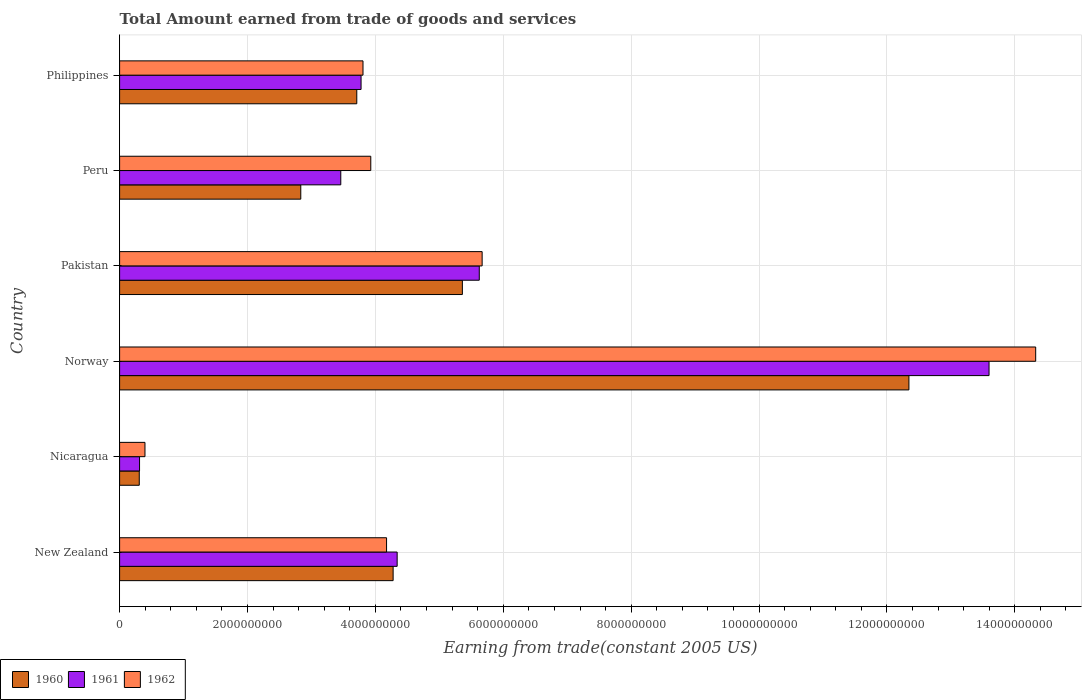How many different coloured bars are there?
Your answer should be compact. 3. How many groups of bars are there?
Provide a succinct answer. 6. Are the number of bars per tick equal to the number of legend labels?
Ensure brevity in your answer.  Yes. How many bars are there on the 6th tick from the top?
Keep it short and to the point. 3. How many bars are there on the 6th tick from the bottom?
Keep it short and to the point. 3. What is the label of the 4th group of bars from the top?
Offer a terse response. Norway. In how many cases, is the number of bars for a given country not equal to the number of legend labels?
Your answer should be compact. 0. What is the total amount earned by trading goods and services in 1960 in New Zealand?
Ensure brevity in your answer.  4.28e+09. Across all countries, what is the maximum total amount earned by trading goods and services in 1962?
Provide a short and direct response. 1.43e+1. Across all countries, what is the minimum total amount earned by trading goods and services in 1960?
Ensure brevity in your answer.  3.07e+08. In which country was the total amount earned by trading goods and services in 1960 minimum?
Your response must be concise. Nicaragua. What is the total total amount earned by trading goods and services in 1962 in the graph?
Provide a succinct answer. 3.23e+1. What is the difference between the total amount earned by trading goods and services in 1960 in Norway and that in Peru?
Keep it short and to the point. 9.51e+09. What is the difference between the total amount earned by trading goods and services in 1962 in Nicaragua and the total amount earned by trading goods and services in 1960 in Philippines?
Ensure brevity in your answer.  -3.31e+09. What is the average total amount earned by trading goods and services in 1960 per country?
Provide a succinct answer. 4.81e+09. What is the difference between the total amount earned by trading goods and services in 1960 and total amount earned by trading goods and services in 1962 in New Zealand?
Ensure brevity in your answer.  1.03e+08. What is the ratio of the total amount earned by trading goods and services in 1961 in New Zealand to that in Pakistan?
Keep it short and to the point. 0.77. Is the total amount earned by trading goods and services in 1960 in New Zealand less than that in Peru?
Your answer should be compact. No. What is the difference between the highest and the second highest total amount earned by trading goods and services in 1960?
Keep it short and to the point. 6.98e+09. What is the difference between the highest and the lowest total amount earned by trading goods and services in 1962?
Your answer should be very brief. 1.39e+1. What does the 1st bar from the top in Norway represents?
Your answer should be very brief. 1962. What does the 2nd bar from the bottom in Nicaragua represents?
Your answer should be very brief. 1961. Is it the case that in every country, the sum of the total amount earned by trading goods and services in 1962 and total amount earned by trading goods and services in 1961 is greater than the total amount earned by trading goods and services in 1960?
Keep it short and to the point. Yes. How many countries are there in the graph?
Your answer should be very brief. 6. Are the values on the major ticks of X-axis written in scientific E-notation?
Offer a terse response. No. Does the graph contain grids?
Keep it short and to the point. Yes. Where does the legend appear in the graph?
Offer a very short reply. Bottom left. How are the legend labels stacked?
Keep it short and to the point. Horizontal. What is the title of the graph?
Offer a very short reply. Total Amount earned from trade of goods and services. Does "1993" appear as one of the legend labels in the graph?
Give a very brief answer. No. What is the label or title of the X-axis?
Your answer should be compact. Earning from trade(constant 2005 US). What is the Earning from trade(constant 2005 US) in 1960 in New Zealand?
Keep it short and to the point. 4.28e+09. What is the Earning from trade(constant 2005 US) of 1961 in New Zealand?
Your answer should be compact. 4.34e+09. What is the Earning from trade(constant 2005 US) in 1962 in New Zealand?
Your answer should be very brief. 4.17e+09. What is the Earning from trade(constant 2005 US) in 1960 in Nicaragua?
Your answer should be compact. 3.07e+08. What is the Earning from trade(constant 2005 US) in 1961 in Nicaragua?
Provide a succinct answer. 3.12e+08. What is the Earning from trade(constant 2005 US) of 1962 in Nicaragua?
Provide a short and direct response. 3.97e+08. What is the Earning from trade(constant 2005 US) in 1960 in Norway?
Offer a very short reply. 1.23e+1. What is the Earning from trade(constant 2005 US) in 1961 in Norway?
Offer a terse response. 1.36e+1. What is the Earning from trade(constant 2005 US) of 1962 in Norway?
Your answer should be compact. 1.43e+1. What is the Earning from trade(constant 2005 US) in 1960 in Pakistan?
Provide a short and direct response. 5.36e+09. What is the Earning from trade(constant 2005 US) in 1961 in Pakistan?
Offer a very short reply. 5.62e+09. What is the Earning from trade(constant 2005 US) in 1962 in Pakistan?
Make the answer very short. 5.67e+09. What is the Earning from trade(constant 2005 US) of 1960 in Peru?
Provide a short and direct response. 2.83e+09. What is the Earning from trade(constant 2005 US) of 1961 in Peru?
Keep it short and to the point. 3.46e+09. What is the Earning from trade(constant 2005 US) in 1962 in Peru?
Your answer should be compact. 3.93e+09. What is the Earning from trade(constant 2005 US) in 1960 in Philippines?
Provide a succinct answer. 3.71e+09. What is the Earning from trade(constant 2005 US) of 1961 in Philippines?
Make the answer very short. 3.78e+09. What is the Earning from trade(constant 2005 US) in 1962 in Philippines?
Offer a very short reply. 3.81e+09. Across all countries, what is the maximum Earning from trade(constant 2005 US) of 1960?
Your response must be concise. 1.23e+1. Across all countries, what is the maximum Earning from trade(constant 2005 US) in 1961?
Your response must be concise. 1.36e+1. Across all countries, what is the maximum Earning from trade(constant 2005 US) of 1962?
Give a very brief answer. 1.43e+1. Across all countries, what is the minimum Earning from trade(constant 2005 US) of 1960?
Provide a succinct answer. 3.07e+08. Across all countries, what is the minimum Earning from trade(constant 2005 US) of 1961?
Provide a succinct answer. 3.12e+08. Across all countries, what is the minimum Earning from trade(constant 2005 US) in 1962?
Offer a terse response. 3.97e+08. What is the total Earning from trade(constant 2005 US) of 1960 in the graph?
Make the answer very short. 2.88e+1. What is the total Earning from trade(constant 2005 US) in 1961 in the graph?
Provide a short and direct response. 3.11e+1. What is the total Earning from trade(constant 2005 US) in 1962 in the graph?
Keep it short and to the point. 3.23e+1. What is the difference between the Earning from trade(constant 2005 US) in 1960 in New Zealand and that in Nicaragua?
Your answer should be compact. 3.97e+09. What is the difference between the Earning from trade(constant 2005 US) of 1961 in New Zealand and that in Nicaragua?
Give a very brief answer. 4.03e+09. What is the difference between the Earning from trade(constant 2005 US) of 1962 in New Zealand and that in Nicaragua?
Your answer should be compact. 3.78e+09. What is the difference between the Earning from trade(constant 2005 US) of 1960 in New Zealand and that in Norway?
Keep it short and to the point. -8.07e+09. What is the difference between the Earning from trade(constant 2005 US) of 1961 in New Zealand and that in Norway?
Give a very brief answer. -9.26e+09. What is the difference between the Earning from trade(constant 2005 US) in 1962 in New Zealand and that in Norway?
Offer a very short reply. -1.02e+1. What is the difference between the Earning from trade(constant 2005 US) in 1960 in New Zealand and that in Pakistan?
Provide a short and direct response. -1.08e+09. What is the difference between the Earning from trade(constant 2005 US) in 1961 in New Zealand and that in Pakistan?
Keep it short and to the point. -1.28e+09. What is the difference between the Earning from trade(constant 2005 US) in 1962 in New Zealand and that in Pakistan?
Your answer should be compact. -1.49e+09. What is the difference between the Earning from trade(constant 2005 US) of 1960 in New Zealand and that in Peru?
Make the answer very short. 1.44e+09. What is the difference between the Earning from trade(constant 2005 US) of 1961 in New Zealand and that in Peru?
Provide a short and direct response. 8.82e+08. What is the difference between the Earning from trade(constant 2005 US) in 1962 in New Zealand and that in Peru?
Offer a very short reply. 2.47e+08. What is the difference between the Earning from trade(constant 2005 US) of 1960 in New Zealand and that in Philippines?
Provide a succinct answer. 5.69e+08. What is the difference between the Earning from trade(constant 2005 US) in 1961 in New Zealand and that in Philippines?
Offer a very short reply. 5.64e+08. What is the difference between the Earning from trade(constant 2005 US) of 1962 in New Zealand and that in Philippines?
Provide a short and direct response. 3.69e+08. What is the difference between the Earning from trade(constant 2005 US) of 1960 in Nicaragua and that in Norway?
Offer a terse response. -1.20e+1. What is the difference between the Earning from trade(constant 2005 US) in 1961 in Nicaragua and that in Norway?
Provide a succinct answer. -1.33e+1. What is the difference between the Earning from trade(constant 2005 US) in 1962 in Nicaragua and that in Norway?
Provide a succinct answer. -1.39e+1. What is the difference between the Earning from trade(constant 2005 US) in 1960 in Nicaragua and that in Pakistan?
Your answer should be compact. -5.05e+09. What is the difference between the Earning from trade(constant 2005 US) of 1961 in Nicaragua and that in Pakistan?
Offer a very short reply. -5.31e+09. What is the difference between the Earning from trade(constant 2005 US) of 1962 in Nicaragua and that in Pakistan?
Offer a terse response. -5.27e+09. What is the difference between the Earning from trade(constant 2005 US) in 1960 in Nicaragua and that in Peru?
Your answer should be compact. -2.53e+09. What is the difference between the Earning from trade(constant 2005 US) of 1961 in Nicaragua and that in Peru?
Offer a terse response. -3.15e+09. What is the difference between the Earning from trade(constant 2005 US) of 1962 in Nicaragua and that in Peru?
Offer a terse response. -3.53e+09. What is the difference between the Earning from trade(constant 2005 US) in 1960 in Nicaragua and that in Philippines?
Ensure brevity in your answer.  -3.40e+09. What is the difference between the Earning from trade(constant 2005 US) in 1961 in Nicaragua and that in Philippines?
Make the answer very short. -3.46e+09. What is the difference between the Earning from trade(constant 2005 US) in 1962 in Nicaragua and that in Philippines?
Provide a short and direct response. -3.41e+09. What is the difference between the Earning from trade(constant 2005 US) of 1960 in Norway and that in Pakistan?
Provide a succinct answer. 6.98e+09. What is the difference between the Earning from trade(constant 2005 US) in 1961 in Norway and that in Pakistan?
Your response must be concise. 7.97e+09. What is the difference between the Earning from trade(constant 2005 US) of 1962 in Norway and that in Pakistan?
Keep it short and to the point. 8.66e+09. What is the difference between the Earning from trade(constant 2005 US) of 1960 in Norway and that in Peru?
Your answer should be compact. 9.51e+09. What is the difference between the Earning from trade(constant 2005 US) of 1961 in Norway and that in Peru?
Provide a short and direct response. 1.01e+1. What is the difference between the Earning from trade(constant 2005 US) in 1962 in Norway and that in Peru?
Offer a terse response. 1.04e+1. What is the difference between the Earning from trade(constant 2005 US) in 1960 in Norway and that in Philippines?
Provide a succinct answer. 8.63e+09. What is the difference between the Earning from trade(constant 2005 US) in 1961 in Norway and that in Philippines?
Ensure brevity in your answer.  9.82e+09. What is the difference between the Earning from trade(constant 2005 US) of 1962 in Norway and that in Philippines?
Offer a very short reply. 1.05e+1. What is the difference between the Earning from trade(constant 2005 US) of 1960 in Pakistan and that in Peru?
Ensure brevity in your answer.  2.53e+09. What is the difference between the Earning from trade(constant 2005 US) in 1961 in Pakistan and that in Peru?
Your answer should be very brief. 2.17e+09. What is the difference between the Earning from trade(constant 2005 US) in 1962 in Pakistan and that in Peru?
Keep it short and to the point. 1.74e+09. What is the difference between the Earning from trade(constant 2005 US) in 1960 in Pakistan and that in Philippines?
Provide a short and direct response. 1.65e+09. What is the difference between the Earning from trade(constant 2005 US) of 1961 in Pakistan and that in Philippines?
Offer a terse response. 1.85e+09. What is the difference between the Earning from trade(constant 2005 US) of 1962 in Pakistan and that in Philippines?
Keep it short and to the point. 1.86e+09. What is the difference between the Earning from trade(constant 2005 US) of 1960 in Peru and that in Philippines?
Offer a very short reply. -8.76e+08. What is the difference between the Earning from trade(constant 2005 US) in 1961 in Peru and that in Philippines?
Your response must be concise. -3.17e+08. What is the difference between the Earning from trade(constant 2005 US) of 1962 in Peru and that in Philippines?
Your response must be concise. 1.22e+08. What is the difference between the Earning from trade(constant 2005 US) of 1960 in New Zealand and the Earning from trade(constant 2005 US) of 1961 in Nicaragua?
Make the answer very short. 3.97e+09. What is the difference between the Earning from trade(constant 2005 US) in 1960 in New Zealand and the Earning from trade(constant 2005 US) in 1962 in Nicaragua?
Provide a succinct answer. 3.88e+09. What is the difference between the Earning from trade(constant 2005 US) in 1961 in New Zealand and the Earning from trade(constant 2005 US) in 1962 in Nicaragua?
Provide a short and direct response. 3.94e+09. What is the difference between the Earning from trade(constant 2005 US) in 1960 in New Zealand and the Earning from trade(constant 2005 US) in 1961 in Norway?
Offer a terse response. -9.32e+09. What is the difference between the Earning from trade(constant 2005 US) in 1960 in New Zealand and the Earning from trade(constant 2005 US) in 1962 in Norway?
Offer a very short reply. -1.00e+1. What is the difference between the Earning from trade(constant 2005 US) of 1961 in New Zealand and the Earning from trade(constant 2005 US) of 1962 in Norway?
Offer a very short reply. -9.99e+09. What is the difference between the Earning from trade(constant 2005 US) in 1960 in New Zealand and the Earning from trade(constant 2005 US) in 1961 in Pakistan?
Your response must be concise. -1.35e+09. What is the difference between the Earning from trade(constant 2005 US) in 1960 in New Zealand and the Earning from trade(constant 2005 US) in 1962 in Pakistan?
Provide a short and direct response. -1.39e+09. What is the difference between the Earning from trade(constant 2005 US) of 1961 in New Zealand and the Earning from trade(constant 2005 US) of 1962 in Pakistan?
Make the answer very short. -1.33e+09. What is the difference between the Earning from trade(constant 2005 US) of 1960 in New Zealand and the Earning from trade(constant 2005 US) of 1961 in Peru?
Provide a succinct answer. 8.19e+08. What is the difference between the Earning from trade(constant 2005 US) of 1960 in New Zealand and the Earning from trade(constant 2005 US) of 1962 in Peru?
Keep it short and to the point. 3.50e+08. What is the difference between the Earning from trade(constant 2005 US) of 1961 in New Zealand and the Earning from trade(constant 2005 US) of 1962 in Peru?
Your response must be concise. 4.13e+08. What is the difference between the Earning from trade(constant 2005 US) in 1960 in New Zealand and the Earning from trade(constant 2005 US) in 1961 in Philippines?
Ensure brevity in your answer.  5.01e+08. What is the difference between the Earning from trade(constant 2005 US) in 1960 in New Zealand and the Earning from trade(constant 2005 US) in 1962 in Philippines?
Provide a short and direct response. 4.71e+08. What is the difference between the Earning from trade(constant 2005 US) in 1961 in New Zealand and the Earning from trade(constant 2005 US) in 1962 in Philippines?
Make the answer very short. 5.34e+08. What is the difference between the Earning from trade(constant 2005 US) of 1960 in Nicaragua and the Earning from trade(constant 2005 US) of 1961 in Norway?
Your response must be concise. -1.33e+1. What is the difference between the Earning from trade(constant 2005 US) of 1960 in Nicaragua and the Earning from trade(constant 2005 US) of 1962 in Norway?
Make the answer very short. -1.40e+1. What is the difference between the Earning from trade(constant 2005 US) of 1961 in Nicaragua and the Earning from trade(constant 2005 US) of 1962 in Norway?
Offer a terse response. -1.40e+1. What is the difference between the Earning from trade(constant 2005 US) in 1960 in Nicaragua and the Earning from trade(constant 2005 US) in 1961 in Pakistan?
Offer a very short reply. -5.32e+09. What is the difference between the Earning from trade(constant 2005 US) of 1960 in Nicaragua and the Earning from trade(constant 2005 US) of 1962 in Pakistan?
Your response must be concise. -5.36e+09. What is the difference between the Earning from trade(constant 2005 US) in 1961 in Nicaragua and the Earning from trade(constant 2005 US) in 1962 in Pakistan?
Provide a short and direct response. -5.36e+09. What is the difference between the Earning from trade(constant 2005 US) of 1960 in Nicaragua and the Earning from trade(constant 2005 US) of 1961 in Peru?
Provide a succinct answer. -3.15e+09. What is the difference between the Earning from trade(constant 2005 US) in 1960 in Nicaragua and the Earning from trade(constant 2005 US) in 1962 in Peru?
Provide a succinct answer. -3.62e+09. What is the difference between the Earning from trade(constant 2005 US) in 1961 in Nicaragua and the Earning from trade(constant 2005 US) in 1962 in Peru?
Keep it short and to the point. -3.62e+09. What is the difference between the Earning from trade(constant 2005 US) in 1960 in Nicaragua and the Earning from trade(constant 2005 US) in 1961 in Philippines?
Provide a short and direct response. -3.47e+09. What is the difference between the Earning from trade(constant 2005 US) in 1960 in Nicaragua and the Earning from trade(constant 2005 US) in 1962 in Philippines?
Your answer should be compact. -3.50e+09. What is the difference between the Earning from trade(constant 2005 US) of 1961 in Nicaragua and the Earning from trade(constant 2005 US) of 1962 in Philippines?
Make the answer very short. -3.49e+09. What is the difference between the Earning from trade(constant 2005 US) in 1960 in Norway and the Earning from trade(constant 2005 US) in 1961 in Pakistan?
Your response must be concise. 6.72e+09. What is the difference between the Earning from trade(constant 2005 US) of 1960 in Norway and the Earning from trade(constant 2005 US) of 1962 in Pakistan?
Provide a succinct answer. 6.67e+09. What is the difference between the Earning from trade(constant 2005 US) of 1961 in Norway and the Earning from trade(constant 2005 US) of 1962 in Pakistan?
Provide a short and direct response. 7.93e+09. What is the difference between the Earning from trade(constant 2005 US) of 1960 in Norway and the Earning from trade(constant 2005 US) of 1961 in Peru?
Your answer should be compact. 8.88e+09. What is the difference between the Earning from trade(constant 2005 US) in 1960 in Norway and the Earning from trade(constant 2005 US) in 1962 in Peru?
Keep it short and to the point. 8.42e+09. What is the difference between the Earning from trade(constant 2005 US) in 1961 in Norway and the Earning from trade(constant 2005 US) in 1962 in Peru?
Offer a very short reply. 9.67e+09. What is the difference between the Earning from trade(constant 2005 US) of 1960 in Norway and the Earning from trade(constant 2005 US) of 1961 in Philippines?
Offer a terse response. 8.57e+09. What is the difference between the Earning from trade(constant 2005 US) in 1960 in Norway and the Earning from trade(constant 2005 US) in 1962 in Philippines?
Your response must be concise. 8.54e+09. What is the difference between the Earning from trade(constant 2005 US) of 1961 in Norway and the Earning from trade(constant 2005 US) of 1962 in Philippines?
Your answer should be compact. 9.79e+09. What is the difference between the Earning from trade(constant 2005 US) in 1960 in Pakistan and the Earning from trade(constant 2005 US) in 1961 in Peru?
Offer a very short reply. 1.90e+09. What is the difference between the Earning from trade(constant 2005 US) in 1960 in Pakistan and the Earning from trade(constant 2005 US) in 1962 in Peru?
Give a very brief answer. 1.43e+09. What is the difference between the Earning from trade(constant 2005 US) in 1961 in Pakistan and the Earning from trade(constant 2005 US) in 1962 in Peru?
Your answer should be very brief. 1.70e+09. What is the difference between the Earning from trade(constant 2005 US) in 1960 in Pakistan and the Earning from trade(constant 2005 US) in 1961 in Philippines?
Your answer should be very brief. 1.58e+09. What is the difference between the Earning from trade(constant 2005 US) of 1960 in Pakistan and the Earning from trade(constant 2005 US) of 1962 in Philippines?
Your response must be concise. 1.55e+09. What is the difference between the Earning from trade(constant 2005 US) in 1961 in Pakistan and the Earning from trade(constant 2005 US) in 1962 in Philippines?
Provide a succinct answer. 1.82e+09. What is the difference between the Earning from trade(constant 2005 US) of 1960 in Peru and the Earning from trade(constant 2005 US) of 1961 in Philippines?
Provide a short and direct response. -9.43e+08. What is the difference between the Earning from trade(constant 2005 US) of 1960 in Peru and the Earning from trade(constant 2005 US) of 1962 in Philippines?
Keep it short and to the point. -9.73e+08. What is the difference between the Earning from trade(constant 2005 US) of 1961 in Peru and the Earning from trade(constant 2005 US) of 1962 in Philippines?
Your answer should be compact. -3.47e+08. What is the average Earning from trade(constant 2005 US) in 1960 per country?
Your response must be concise. 4.81e+09. What is the average Earning from trade(constant 2005 US) in 1961 per country?
Offer a very short reply. 5.18e+09. What is the average Earning from trade(constant 2005 US) in 1962 per country?
Your answer should be compact. 5.38e+09. What is the difference between the Earning from trade(constant 2005 US) in 1960 and Earning from trade(constant 2005 US) in 1961 in New Zealand?
Provide a short and direct response. -6.30e+07. What is the difference between the Earning from trade(constant 2005 US) of 1960 and Earning from trade(constant 2005 US) of 1962 in New Zealand?
Keep it short and to the point. 1.03e+08. What is the difference between the Earning from trade(constant 2005 US) in 1961 and Earning from trade(constant 2005 US) in 1962 in New Zealand?
Give a very brief answer. 1.66e+08. What is the difference between the Earning from trade(constant 2005 US) of 1960 and Earning from trade(constant 2005 US) of 1961 in Nicaragua?
Ensure brevity in your answer.  -4.39e+06. What is the difference between the Earning from trade(constant 2005 US) of 1960 and Earning from trade(constant 2005 US) of 1962 in Nicaragua?
Make the answer very short. -8.93e+07. What is the difference between the Earning from trade(constant 2005 US) in 1961 and Earning from trade(constant 2005 US) in 1962 in Nicaragua?
Provide a short and direct response. -8.49e+07. What is the difference between the Earning from trade(constant 2005 US) of 1960 and Earning from trade(constant 2005 US) of 1961 in Norway?
Make the answer very short. -1.25e+09. What is the difference between the Earning from trade(constant 2005 US) of 1960 and Earning from trade(constant 2005 US) of 1962 in Norway?
Provide a succinct answer. -1.98e+09. What is the difference between the Earning from trade(constant 2005 US) in 1961 and Earning from trade(constant 2005 US) in 1962 in Norway?
Provide a short and direct response. -7.29e+08. What is the difference between the Earning from trade(constant 2005 US) of 1960 and Earning from trade(constant 2005 US) of 1961 in Pakistan?
Provide a succinct answer. -2.64e+08. What is the difference between the Earning from trade(constant 2005 US) of 1960 and Earning from trade(constant 2005 US) of 1962 in Pakistan?
Your answer should be very brief. -3.09e+08. What is the difference between the Earning from trade(constant 2005 US) in 1961 and Earning from trade(constant 2005 US) in 1962 in Pakistan?
Ensure brevity in your answer.  -4.48e+07. What is the difference between the Earning from trade(constant 2005 US) of 1960 and Earning from trade(constant 2005 US) of 1961 in Peru?
Your answer should be very brief. -6.26e+08. What is the difference between the Earning from trade(constant 2005 US) in 1960 and Earning from trade(constant 2005 US) in 1962 in Peru?
Offer a very short reply. -1.09e+09. What is the difference between the Earning from trade(constant 2005 US) of 1961 and Earning from trade(constant 2005 US) of 1962 in Peru?
Provide a short and direct response. -4.69e+08. What is the difference between the Earning from trade(constant 2005 US) in 1960 and Earning from trade(constant 2005 US) in 1961 in Philippines?
Your answer should be very brief. -6.71e+07. What is the difference between the Earning from trade(constant 2005 US) of 1960 and Earning from trade(constant 2005 US) of 1962 in Philippines?
Make the answer very short. -9.73e+07. What is the difference between the Earning from trade(constant 2005 US) of 1961 and Earning from trade(constant 2005 US) of 1962 in Philippines?
Your response must be concise. -3.02e+07. What is the ratio of the Earning from trade(constant 2005 US) in 1960 in New Zealand to that in Nicaragua?
Your answer should be compact. 13.92. What is the ratio of the Earning from trade(constant 2005 US) of 1961 in New Zealand to that in Nicaragua?
Keep it short and to the point. 13.92. What is the ratio of the Earning from trade(constant 2005 US) in 1962 in New Zealand to that in Nicaragua?
Offer a very short reply. 10.52. What is the ratio of the Earning from trade(constant 2005 US) of 1960 in New Zealand to that in Norway?
Offer a very short reply. 0.35. What is the ratio of the Earning from trade(constant 2005 US) in 1961 in New Zealand to that in Norway?
Ensure brevity in your answer.  0.32. What is the ratio of the Earning from trade(constant 2005 US) in 1962 in New Zealand to that in Norway?
Provide a short and direct response. 0.29. What is the ratio of the Earning from trade(constant 2005 US) of 1960 in New Zealand to that in Pakistan?
Offer a terse response. 0.8. What is the ratio of the Earning from trade(constant 2005 US) in 1961 in New Zealand to that in Pakistan?
Your answer should be very brief. 0.77. What is the ratio of the Earning from trade(constant 2005 US) in 1962 in New Zealand to that in Pakistan?
Provide a succinct answer. 0.74. What is the ratio of the Earning from trade(constant 2005 US) of 1960 in New Zealand to that in Peru?
Your answer should be very brief. 1.51. What is the ratio of the Earning from trade(constant 2005 US) of 1961 in New Zealand to that in Peru?
Your answer should be very brief. 1.25. What is the ratio of the Earning from trade(constant 2005 US) of 1962 in New Zealand to that in Peru?
Give a very brief answer. 1.06. What is the ratio of the Earning from trade(constant 2005 US) in 1960 in New Zealand to that in Philippines?
Offer a very short reply. 1.15. What is the ratio of the Earning from trade(constant 2005 US) in 1961 in New Zealand to that in Philippines?
Your answer should be very brief. 1.15. What is the ratio of the Earning from trade(constant 2005 US) in 1962 in New Zealand to that in Philippines?
Provide a short and direct response. 1.1. What is the ratio of the Earning from trade(constant 2005 US) in 1960 in Nicaragua to that in Norway?
Your answer should be very brief. 0.02. What is the ratio of the Earning from trade(constant 2005 US) in 1961 in Nicaragua to that in Norway?
Your answer should be very brief. 0.02. What is the ratio of the Earning from trade(constant 2005 US) in 1962 in Nicaragua to that in Norway?
Give a very brief answer. 0.03. What is the ratio of the Earning from trade(constant 2005 US) in 1960 in Nicaragua to that in Pakistan?
Give a very brief answer. 0.06. What is the ratio of the Earning from trade(constant 2005 US) of 1961 in Nicaragua to that in Pakistan?
Your answer should be very brief. 0.06. What is the ratio of the Earning from trade(constant 2005 US) in 1962 in Nicaragua to that in Pakistan?
Your answer should be compact. 0.07. What is the ratio of the Earning from trade(constant 2005 US) of 1960 in Nicaragua to that in Peru?
Offer a terse response. 0.11. What is the ratio of the Earning from trade(constant 2005 US) in 1961 in Nicaragua to that in Peru?
Your answer should be very brief. 0.09. What is the ratio of the Earning from trade(constant 2005 US) of 1962 in Nicaragua to that in Peru?
Offer a very short reply. 0.1. What is the ratio of the Earning from trade(constant 2005 US) in 1960 in Nicaragua to that in Philippines?
Make the answer very short. 0.08. What is the ratio of the Earning from trade(constant 2005 US) in 1961 in Nicaragua to that in Philippines?
Your response must be concise. 0.08. What is the ratio of the Earning from trade(constant 2005 US) in 1962 in Nicaragua to that in Philippines?
Provide a succinct answer. 0.1. What is the ratio of the Earning from trade(constant 2005 US) in 1960 in Norway to that in Pakistan?
Provide a succinct answer. 2.3. What is the ratio of the Earning from trade(constant 2005 US) of 1961 in Norway to that in Pakistan?
Make the answer very short. 2.42. What is the ratio of the Earning from trade(constant 2005 US) of 1962 in Norway to that in Pakistan?
Your answer should be compact. 2.53. What is the ratio of the Earning from trade(constant 2005 US) in 1960 in Norway to that in Peru?
Give a very brief answer. 4.36. What is the ratio of the Earning from trade(constant 2005 US) of 1961 in Norway to that in Peru?
Make the answer very short. 3.93. What is the ratio of the Earning from trade(constant 2005 US) in 1962 in Norway to that in Peru?
Offer a terse response. 3.65. What is the ratio of the Earning from trade(constant 2005 US) in 1960 in Norway to that in Philippines?
Make the answer very short. 3.33. What is the ratio of the Earning from trade(constant 2005 US) of 1961 in Norway to that in Philippines?
Give a very brief answer. 3.6. What is the ratio of the Earning from trade(constant 2005 US) of 1962 in Norway to that in Philippines?
Ensure brevity in your answer.  3.76. What is the ratio of the Earning from trade(constant 2005 US) of 1960 in Pakistan to that in Peru?
Provide a succinct answer. 1.89. What is the ratio of the Earning from trade(constant 2005 US) in 1961 in Pakistan to that in Peru?
Ensure brevity in your answer.  1.63. What is the ratio of the Earning from trade(constant 2005 US) in 1962 in Pakistan to that in Peru?
Offer a terse response. 1.44. What is the ratio of the Earning from trade(constant 2005 US) in 1960 in Pakistan to that in Philippines?
Keep it short and to the point. 1.45. What is the ratio of the Earning from trade(constant 2005 US) of 1961 in Pakistan to that in Philippines?
Your response must be concise. 1.49. What is the ratio of the Earning from trade(constant 2005 US) of 1962 in Pakistan to that in Philippines?
Offer a terse response. 1.49. What is the ratio of the Earning from trade(constant 2005 US) in 1960 in Peru to that in Philippines?
Provide a short and direct response. 0.76. What is the ratio of the Earning from trade(constant 2005 US) of 1961 in Peru to that in Philippines?
Offer a very short reply. 0.92. What is the ratio of the Earning from trade(constant 2005 US) of 1962 in Peru to that in Philippines?
Keep it short and to the point. 1.03. What is the difference between the highest and the second highest Earning from trade(constant 2005 US) of 1960?
Keep it short and to the point. 6.98e+09. What is the difference between the highest and the second highest Earning from trade(constant 2005 US) of 1961?
Your answer should be compact. 7.97e+09. What is the difference between the highest and the second highest Earning from trade(constant 2005 US) in 1962?
Your response must be concise. 8.66e+09. What is the difference between the highest and the lowest Earning from trade(constant 2005 US) in 1960?
Provide a succinct answer. 1.20e+1. What is the difference between the highest and the lowest Earning from trade(constant 2005 US) of 1961?
Give a very brief answer. 1.33e+1. What is the difference between the highest and the lowest Earning from trade(constant 2005 US) in 1962?
Make the answer very short. 1.39e+1. 